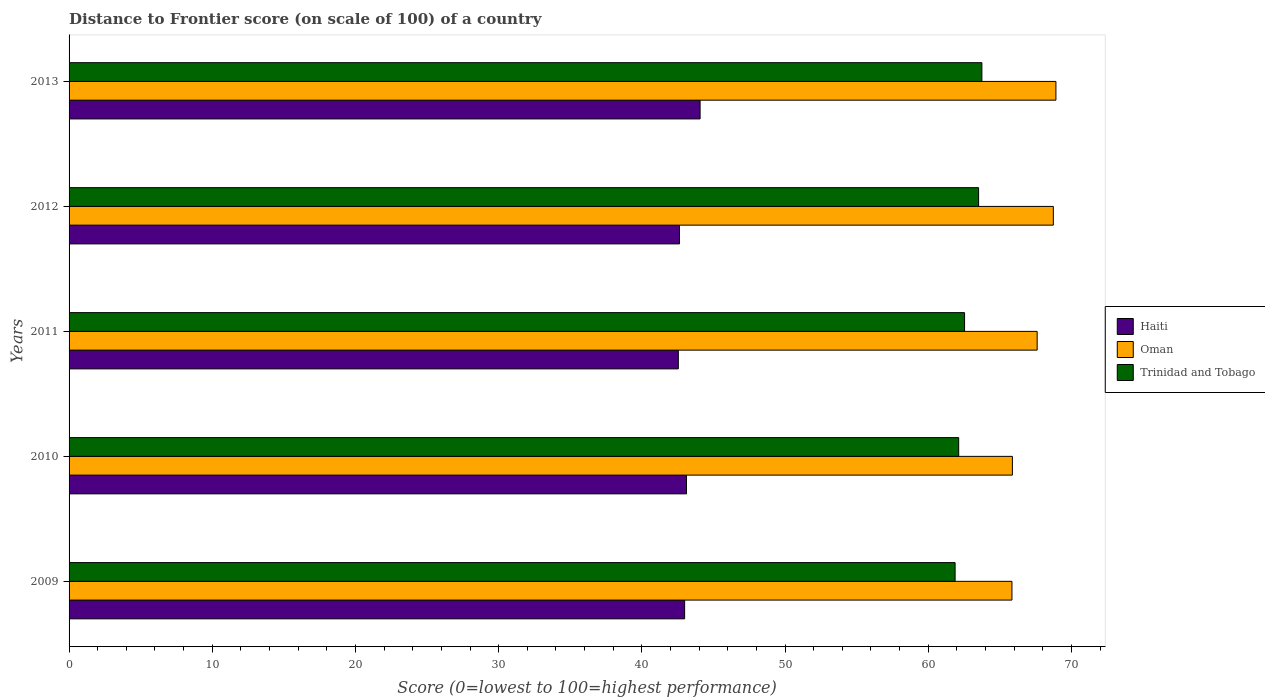How many bars are there on the 4th tick from the top?
Your answer should be compact. 3. What is the distance to frontier score of in Trinidad and Tobago in 2011?
Make the answer very short. 62.54. Across all years, what is the maximum distance to frontier score of in Trinidad and Tobago?
Ensure brevity in your answer.  63.75. Across all years, what is the minimum distance to frontier score of in Oman?
Provide a succinct answer. 65.85. In which year was the distance to frontier score of in Trinidad and Tobago maximum?
Your answer should be compact. 2013. In which year was the distance to frontier score of in Haiti minimum?
Offer a very short reply. 2011. What is the total distance to frontier score of in Trinidad and Tobago in the graph?
Your response must be concise. 313.82. What is the difference between the distance to frontier score of in Trinidad and Tobago in 2010 and that in 2013?
Your answer should be very brief. -1.62. What is the difference between the distance to frontier score of in Trinidad and Tobago in 2013 and the distance to frontier score of in Haiti in 2012?
Ensure brevity in your answer.  21.12. What is the average distance to frontier score of in Haiti per year?
Give a very brief answer. 43.07. In the year 2013, what is the difference between the distance to frontier score of in Oman and distance to frontier score of in Haiti?
Your answer should be very brief. 24.85. In how many years, is the distance to frontier score of in Trinidad and Tobago greater than 10 ?
Provide a succinct answer. 5. What is the ratio of the distance to frontier score of in Haiti in 2011 to that in 2013?
Keep it short and to the point. 0.97. Is the distance to frontier score of in Oman in 2009 less than that in 2011?
Make the answer very short. Yes. What is the difference between the highest and the second highest distance to frontier score of in Haiti?
Give a very brief answer. 0.95. What is the difference between the highest and the lowest distance to frontier score of in Oman?
Provide a short and direct response. 3.07. In how many years, is the distance to frontier score of in Trinidad and Tobago greater than the average distance to frontier score of in Trinidad and Tobago taken over all years?
Provide a short and direct response. 2. What does the 3rd bar from the top in 2010 represents?
Keep it short and to the point. Haiti. What does the 1st bar from the bottom in 2011 represents?
Your answer should be compact. Haiti. What is the difference between two consecutive major ticks on the X-axis?
Your response must be concise. 10. Does the graph contain any zero values?
Make the answer very short. No. What is the title of the graph?
Keep it short and to the point. Distance to Frontier score (on scale of 100) of a country. Does "Thailand" appear as one of the legend labels in the graph?
Ensure brevity in your answer.  No. What is the label or title of the X-axis?
Offer a very short reply. Score (0=lowest to 100=highest performance). What is the Score (0=lowest to 100=highest performance) in Haiti in 2009?
Keep it short and to the point. 42.99. What is the Score (0=lowest to 100=highest performance) of Oman in 2009?
Make the answer very short. 65.85. What is the Score (0=lowest to 100=highest performance) of Trinidad and Tobago in 2009?
Your answer should be compact. 61.88. What is the Score (0=lowest to 100=highest performance) in Haiti in 2010?
Keep it short and to the point. 43.12. What is the Score (0=lowest to 100=highest performance) of Oman in 2010?
Offer a very short reply. 65.88. What is the Score (0=lowest to 100=highest performance) of Trinidad and Tobago in 2010?
Keep it short and to the point. 62.13. What is the Score (0=lowest to 100=highest performance) of Haiti in 2011?
Provide a succinct answer. 42.55. What is the Score (0=lowest to 100=highest performance) of Oman in 2011?
Your answer should be compact. 67.61. What is the Score (0=lowest to 100=highest performance) of Trinidad and Tobago in 2011?
Keep it short and to the point. 62.54. What is the Score (0=lowest to 100=highest performance) in Haiti in 2012?
Your answer should be compact. 42.63. What is the Score (0=lowest to 100=highest performance) in Oman in 2012?
Keep it short and to the point. 68.74. What is the Score (0=lowest to 100=highest performance) in Trinidad and Tobago in 2012?
Offer a terse response. 63.52. What is the Score (0=lowest to 100=highest performance) of Haiti in 2013?
Give a very brief answer. 44.07. What is the Score (0=lowest to 100=highest performance) of Oman in 2013?
Provide a succinct answer. 68.92. What is the Score (0=lowest to 100=highest performance) in Trinidad and Tobago in 2013?
Ensure brevity in your answer.  63.75. Across all years, what is the maximum Score (0=lowest to 100=highest performance) of Haiti?
Give a very brief answer. 44.07. Across all years, what is the maximum Score (0=lowest to 100=highest performance) of Oman?
Provide a short and direct response. 68.92. Across all years, what is the maximum Score (0=lowest to 100=highest performance) in Trinidad and Tobago?
Ensure brevity in your answer.  63.75. Across all years, what is the minimum Score (0=lowest to 100=highest performance) in Haiti?
Give a very brief answer. 42.55. Across all years, what is the minimum Score (0=lowest to 100=highest performance) in Oman?
Ensure brevity in your answer.  65.85. Across all years, what is the minimum Score (0=lowest to 100=highest performance) in Trinidad and Tobago?
Ensure brevity in your answer.  61.88. What is the total Score (0=lowest to 100=highest performance) in Haiti in the graph?
Your answer should be compact. 215.36. What is the total Score (0=lowest to 100=highest performance) in Oman in the graph?
Ensure brevity in your answer.  337. What is the total Score (0=lowest to 100=highest performance) of Trinidad and Tobago in the graph?
Offer a very short reply. 313.82. What is the difference between the Score (0=lowest to 100=highest performance) of Haiti in 2009 and that in 2010?
Provide a short and direct response. -0.13. What is the difference between the Score (0=lowest to 100=highest performance) of Oman in 2009 and that in 2010?
Your answer should be compact. -0.03. What is the difference between the Score (0=lowest to 100=highest performance) of Trinidad and Tobago in 2009 and that in 2010?
Provide a succinct answer. -0.25. What is the difference between the Score (0=lowest to 100=highest performance) in Haiti in 2009 and that in 2011?
Ensure brevity in your answer.  0.44. What is the difference between the Score (0=lowest to 100=highest performance) in Oman in 2009 and that in 2011?
Offer a terse response. -1.76. What is the difference between the Score (0=lowest to 100=highest performance) of Trinidad and Tobago in 2009 and that in 2011?
Your answer should be compact. -0.66. What is the difference between the Score (0=lowest to 100=highest performance) of Haiti in 2009 and that in 2012?
Provide a succinct answer. 0.36. What is the difference between the Score (0=lowest to 100=highest performance) of Oman in 2009 and that in 2012?
Your answer should be compact. -2.89. What is the difference between the Score (0=lowest to 100=highest performance) in Trinidad and Tobago in 2009 and that in 2012?
Offer a very short reply. -1.64. What is the difference between the Score (0=lowest to 100=highest performance) in Haiti in 2009 and that in 2013?
Give a very brief answer. -1.08. What is the difference between the Score (0=lowest to 100=highest performance) of Oman in 2009 and that in 2013?
Give a very brief answer. -3.07. What is the difference between the Score (0=lowest to 100=highest performance) of Trinidad and Tobago in 2009 and that in 2013?
Your answer should be very brief. -1.87. What is the difference between the Score (0=lowest to 100=highest performance) in Haiti in 2010 and that in 2011?
Offer a terse response. 0.57. What is the difference between the Score (0=lowest to 100=highest performance) of Oman in 2010 and that in 2011?
Your response must be concise. -1.73. What is the difference between the Score (0=lowest to 100=highest performance) of Trinidad and Tobago in 2010 and that in 2011?
Provide a short and direct response. -0.41. What is the difference between the Score (0=lowest to 100=highest performance) of Haiti in 2010 and that in 2012?
Your answer should be very brief. 0.49. What is the difference between the Score (0=lowest to 100=highest performance) in Oman in 2010 and that in 2012?
Your response must be concise. -2.86. What is the difference between the Score (0=lowest to 100=highest performance) of Trinidad and Tobago in 2010 and that in 2012?
Offer a terse response. -1.39. What is the difference between the Score (0=lowest to 100=highest performance) of Haiti in 2010 and that in 2013?
Provide a succinct answer. -0.95. What is the difference between the Score (0=lowest to 100=highest performance) in Oman in 2010 and that in 2013?
Offer a very short reply. -3.04. What is the difference between the Score (0=lowest to 100=highest performance) of Trinidad and Tobago in 2010 and that in 2013?
Keep it short and to the point. -1.62. What is the difference between the Score (0=lowest to 100=highest performance) of Haiti in 2011 and that in 2012?
Provide a short and direct response. -0.08. What is the difference between the Score (0=lowest to 100=highest performance) of Oman in 2011 and that in 2012?
Provide a short and direct response. -1.13. What is the difference between the Score (0=lowest to 100=highest performance) in Trinidad and Tobago in 2011 and that in 2012?
Make the answer very short. -0.98. What is the difference between the Score (0=lowest to 100=highest performance) of Haiti in 2011 and that in 2013?
Your answer should be very brief. -1.52. What is the difference between the Score (0=lowest to 100=highest performance) of Oman in 2011 and that in 2013?
Ensure brevity in your answer.  -1.31. What is the difference between the Score (0=lowest to 100=highest performance) in Trinidad and Tobago in 2011 and that in 2013?
Offer a terse response. -1.21. What is the difference between the Score (0=lowest to 100=highest performance) of Haiti in 2012 and that in 2013?
Make the answer very short. -1.44. What is the difference between the Score (0=lowest to 100=highest performance) in Oman in 2012 and that in 2013?
Ensure brevity in your answer.  -0.18. What is the difference between the Score (0=lowest to 100=highest performance) of Trinidad and Tobago in 2012 and that in 2013?
Keep it short and to the point. -0.23. What is the difference between the Score (0=lowest to 100=highest performance) of Haiti in 2009 and the Score (0=lowest to 100=highest performance) of Oman in 2010?
Provide a short and direct response. -22.89. What is the difference between the Score (0=lowest to 100=highest performance) in Haiti in 2009 and the Score (0=lowest to 100=highest performance) in Trinidad and Tobago in 2010?
Offer a very short reply. -19.14. What is the difference between the Score (0=lowest to 100=highest performance) in Oman in 2009 and the Score (0=lowest to 100=highest performance) in Trinidad and Tobago in 2010?
Offer a very short reply. 3.72. What is the difference between the Score (0=lowest to 100=highest performance) of Haiti in 2009 and the Score (0=lowest to 100=highest performance) of Oman in 2011?
Make the answer very short. -24.62. What is the difference between the Score (0=lowest to 100=highest performance) of Haiti in 2009 and the Score (0=lowest to 100=highest performance) of Trinidad and Tobago in 2011?
Your response must be concise. -19.55. What is the difference between the Score (0=lowest to 100=highest performance) in Oman in 2009 and the Score (0=lowest to 100=highest performance) in Trinidad and Tobago in 2011?
Make the answer very short. 3.31. What is the difference between the Score (0=lowest to 100=highest performance) of Haiti in 2009 and the Score (0=lowest to 100=highest performance) of Oman in 2012?
Your answer should be very brief. -25.75. What is the difference between the Score (0=lowest to 100=highest performance) of Haiti in 2009 and the Score (0=lowest to 100=highest performance) of Trinidad and Tobago in 2012?
Offer a terse response. -20.53. What is the difference between the Score (0=lowest to 100=highest performance) in Oman in 2009 and the Score (0=lowest to 100=highest performance) in Trinidad and Tobago in 2012?
Provide a short and direct response. 2.33. What is the difference between the Score (0=lowest to 100=highest performance) in Haiti in 2009 and the Score (0=lowest to 100=highest performance) in Oman in 2013?
Keep it short and to the point. -25.93. What is the difference between the Score (0=lowest to 100=highest performance) in Haiti in 2009 and the Score (0=lowest to 100=highest performance) in Trinidad and Tobago in 2013?
Keep it short and to the point. -20.76. What is the difference between the Score (0=lowest to 100=highest performance) of Haiti in 2010 and the Score (0=lowest to 100=highest performance) of Oman in 2011?
Your response must be concise. -24.49. What is the difference between the Score (0=lowest to 100=highest performance) in Haiti in 2010 and the Score (0=lowest to 100=highest performance) in Trinidad and Tobago in 2011?
Make the answer very short. -19.42. What is the difference between the Score (0=lowest to 100=highest performance) in Oman in 2010 and the Score (0=lowest to 100=highest performance) in Trinidad and Tobago in 2011?
Provide a short and direct response. 3.34. What is the difference between the Score (0=lowest to 100=highest performance) in Haiti in 2010 and the Score (0=lowest to 100=highest performance) in Oman in 2012?
Keep it short and to the point. -25.62. What is the difference between the Score (0=lowest to 100=highest performance) in Haiti in 2010 and the Score (0=lowest to 100=highest performance) in Trinidad and Tobago in 2012?
Offer a terse response. -20.4. What is the difference between the Score (0=lowest to 100=highest performance) of Oman in 2010 and the Score (0=lowest to 100=highest performance) of Trinidad and Tobago in 2012?
Offer a very short reply. 2.36. What is the difference between the Score (0=lowest to 100=highest performance) in Haiti in 2010 and the Score (0=lowest to 100=highest performance) in Oman in 2013?
Offer a terse response. -25.8. What is the difference between the Score (0=lowest to 100=highest performance) of Haiti in 2010 and the Score (0=lowest to 100=highest performance) of Trinidad and Tobago in 2013?
Offer a very short reply. -20.63. What is the difference between the Score (0=lowest to 100=highest performance) in Oman in 2010 and the Score (0=lowest to 100=highest performance) in Trinidad and Tobago in 2013?
Ensure brevity in your answer.  2.13. What is the difference between the Score (0=lowest to 100=highest performance) in Haiti in 2011 and the Score (0=lowest to 100=highest performance) in Oman in 2012?
Offer a terse response. -26.19. What is the difference between the Score (0=lowest to 100=highest performance) of Haiti in 2011 and the Score (0=lowest to 100=highest performance) of Trinidad and Tobago in 2012?
Provide a succinct answer. -20.97. What is the difference between the Score (0=lowest to 100=highest performance) in Oman in 2011 and the Score (0=lowest to 100=highest performance) in Trinidad and Tobago in 2012?
Give a very brief answer. 4.09. What is the difference between the Score (0=lowest to 100=highest performance) of Haiti in 2011 and the Score (0=lowest to 100=highest performance) of Oman in 2013?
Provide a succinct answer. -26.37. What is the difference between the Score (0=lowest to 100=highest performance) in Haiti in 2011 and the Score (0=lowest to 100=highest performance) in Trinidad and Tobago in 2013?
Ensure brevity in your answer.  -21.2. What is the difference between the Score (0=lowest to 100=highest performance) in Oman in 2011 and the Score (0=lowest to 100=highest performance) in Trinidad and Tobago in 2013?
Offer a very short reply. 3.86. What is the difference between the Score (0=lowest to 100=highest performance) in Haiti in 2012 and the Score (0=lowest to 100=highest performance) in Oman in 2013?
Keep it short and to the point. -26.29. What is the difference between the Score (0=lowest to 100=highest performance) of Haiti in 2012 and the Score (0=lowest to 100=highest performance) of Trinidad and Tobago in 2013?
Offer a very short reply. -21.12. What is the difference between the Score (0=lowest to 100=highest performance) of Oman in 2012 and the Score (0=lowest to 100=highest performance) of Trinidad and Tobago in 2013?
Provide a succinct answer. 4.99. What is the average Score (0=lowest to 100=highest performance) of Haiti per year?
Offer a very short reply. 43.07. What is the average Score (0=lowest to 100=highest performance) of Oman per year?
Provide a succinct answer. 67.4. What is the average Score (0=lowest to 100=highest performance) of Trinidad and Tobago per year?
Ensure brevity in your answer.  62.76. In the year 2009, what is the difference between the Score (0=lowest to 100=highest performance) in Haiti and Score (0=lowest to 100=highest performance) in Oman?
Keep it short and to the point. -22.86. In the year 2009, what is the difference between the Score (0=lowest to 100=highest performance) in Haiti and Score (0=lowest to 100=highest performance) in Trinidad and Tobago?
Make the answer very short. -18.89. In the year 2009, what is the difference between the Score (0=lowest to 100=highest performance) in Oman and Score (0=lowest to 100=highest performance) in Trinidad and Tobago?
Provide a succinct answer. 3.97. In the year 2010, what is the difference between the Score (0=lowest to 100=highest performance) in Haiti and Score (0=lowest to 100=highest performance) in Oman?
Offer a terse response. -22.76. In the year 2010, what is the difference between the Score (0=lowest to 100=highest performance) of Haiti and Score (0=lowest to 100=highest performance) of Trinidad and Tobago?
Provide a short and direct response. -19.01. In the year 2010, what is the difference between the Score (0=lowest to 100=highest performance) in Oman and Score (0=lowest to 100=highest performance) in Trinidad and Tobago?
Offer a terse response. 3.75. In the year 2011, what is the difference between the Score (0=lowest to 100=highest performance) in Haiti and Score (0=lowest to 100=highest performance) in Oman?
Offer a terse response. -25.06. In the year 2011, what is the difference between the Score (0=lowest to 100=highest performance) in Haiti and Score (0=lowest to 100=highest performance) in Trinidad and Tobago?
Provide a short and direct response. -19.99. In the year 2011, what is the difference between the Score (0=lowest to 100=highest performance) of Oman and Score (0=lowest to 100=highest performance) of Trinidad and Tobago?
Make the answer very short. 5.07. In the year 2012, what is the difference between the Score (0=lowest to 100=highest performance) of Haiti and Score (0=lowest to 100=highest performance) of Oman?
Keep it short and to the point. -26.11. In the year 2012, what is the difference between the Score (0=lowest to 100=highest performance) of Haiti and Score (0=lowest to 100=highest performance) of Trinidad and Tobago?
Your answer should be very brief. -20.89. In the year 2012, what is the difference between the Score (0=lowest to 100=highest performance) in Oman and Score (0=lowest to 100=highest performance) in Trinidad and Tobago?
Your answer should be very brief. 5.22. In the year 2013, what is the difference between the Score (0=lowest to 100=highest performance) in Haiti and Score (0=lowest to 100=highest performance) in Oman?
Your answer should be very brief. -24.85. In the year 2013, what is the difference between the Score (0=lowest to 100=highest performance) in Haiti and Score (0=lowest to 100=highest performance) in Trinidad and Tobago?
Make the answer very short. -19.68. In the year 2013, what is the difference between the Score (0=lowest to 100=highest performance) of Oman and Score (0=lowest to 100=highest performance) of Trinidad and Tobago?
Give a very brief answer. 5.17. What is the ratio of the Score (0=lowest to 100=highest performance) in Haiti in 2009 to that in 2011?
Give a very brief answer. 1.01. What is the ratio of the Score (0=lowest to 100=highest performance) in Oman in 2009 to that in 2011?
Your answer should be compact. 0.97. What is the ratio of the Score (0=lowest to 100=highest performance) in Trinidad and Tobago in 2009 to that in 2011?
Make the answer very short. 0.99. What is the ratio of the Score (0=lowest to 100=highest performance) in Haiti in 2009 to that in 2012?
Provide a short and direct response. 1.01. What is the ratio of the Score (0=lowest to 100=highest performance) of Oman in 2009 to that in 2012?
Ensure brevity in your answer.  0.96. What is the ratio of the Score (0=lowest to 100=highest performance) of Trinidad and Tobago in 2009 to that in 2012?
Keep it short and to the point. 0.97. What is the ratio of the Score (0=lowest to 100=highest performance) of Haiti in 2009 to that in 2013?
Your response must be concise. 0.98. What is the ratio of the Score (0=lowest to 100=highest performance) of Oman in 2009 to that in 2013?
Provide a succinct answer. 0.96. What is the ratio of the Score (0=lowest to 100=highest performance) of Trinidad and Tobago in 2009 to that in 2013?
Make the answer very short. 0.97. What is the ratio of the Score (0=lowest to 100=highest performance) of Haiti in 2010 to that in 2011?
Your response must be concise. 1.01. What is the ratio of the Score (0=lowest to 100=highest performance) in Oman in 2010 to that in 2011?
Give a very brief answer. 0.97. What is the ratio of the Score (0=lowest to 100=highest performance) in Trinidad and Tobago in 2010 to that in 2011?
Provide a short and direct response. 0.99. What is the ratio of the Score (0=lowest to 100=highest performance) in Haiti in 2010 to that in 2012?
Make the answer very short. 1.01. What is the ratio of the Score (0=lowest to 100=highest performance) in Oman in 2010 to that in 2012?
Provide a succinct answer. 0.96. What is the ratio of the Score (0=lowest to 100=highest performance) in Trinidad and Tobago in 2010 to that in 2012?
Offer a very short reply. 0.98. What is the ratio of the Score (0=lowest to 100=highest performance) in Haiti in 2010 to that in 2013?
Your answer should be very brief. 0.98. What is the ratio of the Score (0=lowest to 100=highest performance) of Oman in 2010 to that in 2013?
Your answer should be very brief. 0.96. What is the ratio of the Score (0=lowest to 100=highest performance) in Trinidad and Tobago in 2010 to that in 2013?
Ensure brevity in your answer.  0.97. What is the ratio of the Score (0=lowest to 100=highest performance) in Oman in 2011 to that in 2012?
Your answer should be compact. 0.98. What is the ratio of the Score (0=lowest to 100=highest performance) of Trinidad and Tobago in 2011 to that in 2012?
Give a very brief answer. 0.98. What is the ratio of the Score (0=lowest to 100=highest performance) of Haiti in 2011 to that in 2013?
Your answer should be compact. 0.97. What is the ratio of the Score (0=lowest to 100=highest performance) in Oman in 2011 to that in 2013?
Give a very brief answer. 0.98. What is the ratio of the Score (0=lowest to 100=highest performance) in Trinidad and Tobago in 2011 to that in 2013?
Provide a succinct answer. 0.98. What is the ratio of the Score (0=lowest to 100=highest performance) in Haiti in 2012 to that in 2013?
Give a very brief answer. 0.97. What is the ratio of the Score (0=lowest to 100=highest performance) of Oman in 2012 to that in 2013?
Your answer should be compact. 1. What is the difference between the highest and the second highest Score (0=lowest to 100=highest performance) of Oman?
Keep it short and to the point. 0.18. What is the difference between the highest and the second highest Score (0=lowest to 100=highest performance) in Trinidad and Tobago?
Your response must be concise. 0.23. What is the difference between the highest and the lowest Score (0=lowest to 100=highest performance) in Haiti?
Provide a succinct answer. 1.52. What is the difference between the highest and the lowest Score (0=lowest to 100=highest performance) in Oman?
Provide a short and direct response. 3.07. What is the difference between the highest and the lowest Score (0=lowest to 100=highest performance) in Trinidad and Tobago?
Your answer should be compact. 1.87. 